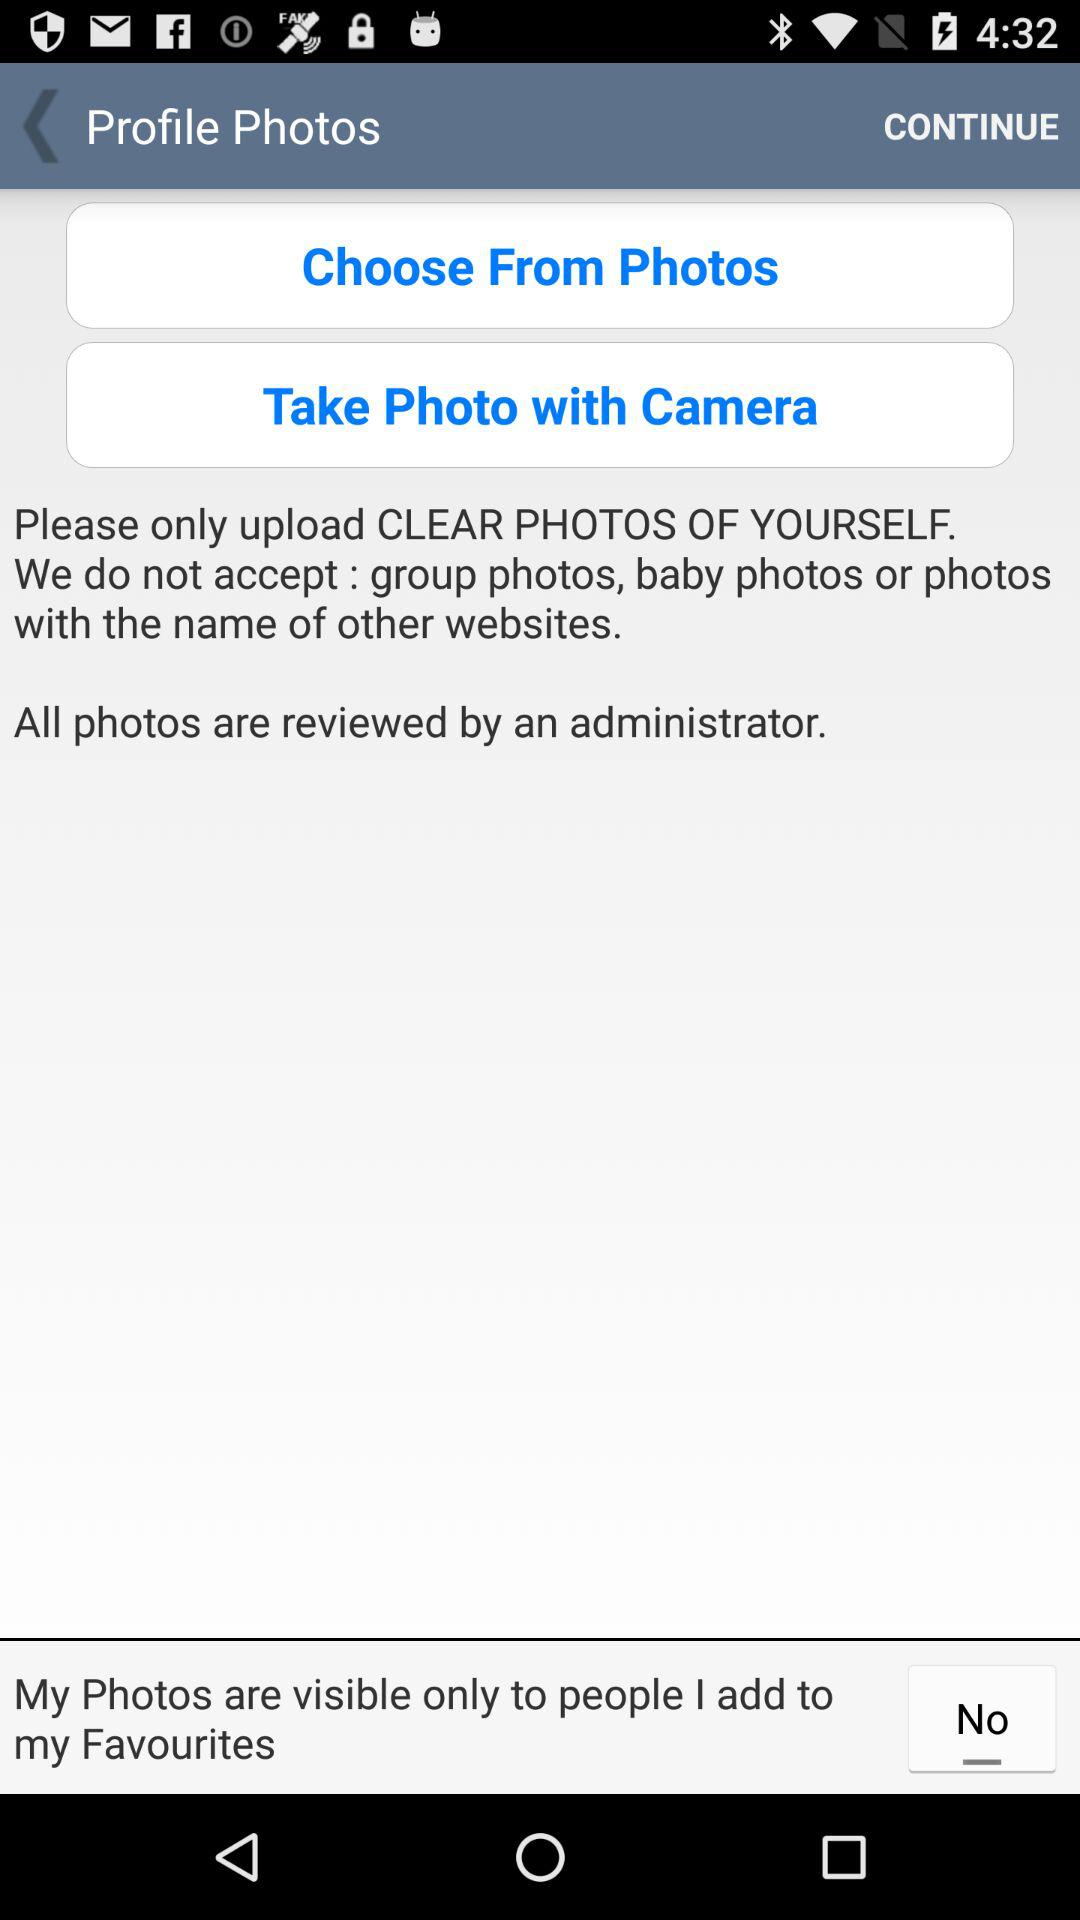What are the two options available in "Profile Photos"? The two options available in "Profile Photos" are "Choose From Photos" and "Take Photo with Camera". 